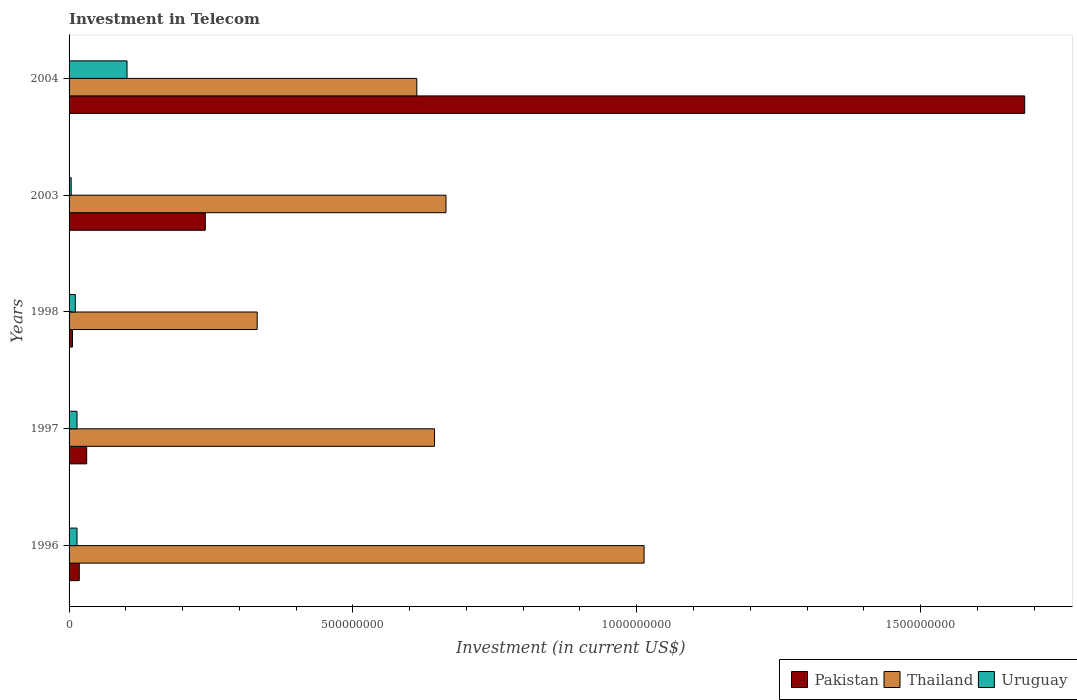How many different coloured bars are there?
Your response must be concise. 3. How many groups of bars are there?
Make the answer very short. 5. Are the number of bars per tick equal to the number of legend labels?
Your answer should be very brief. Yes. How many bars are there on the 4th tick from the top?
Provide a short and direct response. 3. How many bars are there on the 1st tick from the bottom?
Provide a short and direct response. 3. In how many cases, is the number of bars for a given year not equal to the number of legend labels?
Ensure brevity in your answer.  0. What is the amount invested in telecom in Thailand in 1997?
Your answer should be compact. 6.44e+08. Across all years, what is the maximum amount invested in telecom in Pakistan?
Your response must be concise. 1.68e+09. Across all years, what is the minimum amount invested in telecom in Pakistan?
Your response must be concise. 6.00e+06. In which year was the amount invested in telecom in Uruguay minimum?
Give a very brief answer. 2003. What is the total amount invested in telecom in Thailand in the graph?
Offer a very short reply. 3.26e+09. What is the difference between the amount invested in telecom in Uruguay in 1997 and that in 2003?
Your response must be concise. 1.03e+07. What is the difference between the amount invested in telecom in Thailand in 2004 and the amount invested in telecom in Uruguay in 1996?
Offer a very short reply. 5.99e+08. What is the average amount invested in telecom in Pakistan per year?
Provide a succinct answer. 3.96e+08. In the year 2004, what is the difference between the amount invested in telecom in Uruguay and amount invested in telecom in Thailand?
Provide a succinct answer. -5.10e+08. In how many years, is the amount invested in telecom in Uruguay greater than 900000000 US$?
Provide a succinct answer. 0. What is the ratio of the amount invested in telecom in Thailand in 1997 to that in 2004?
Keep it short and to the point. 1.05. What is the difference between the highest and the second highest amount invested in telecom in Pakistan?
Provide a short and direct response. 1.44e+09. What is the difference between the highest and the lowest amount invested in telecom in Uruguay?
Your answer should be compact. 9.84e+07. In how many years, is the amount invested in telecom in Uruguay greater than the average amount invested in telecom in Uruguay taken over all years?
Provide a succinct answer. 1. Is the sum of the amount invested in telecom in Uruguay in 1997 and 1998 greater than the maximum amount invested in telecom in Pakistan across all years?
Your answer should be very brief. No. What does the 2nd bar from the top in 1998 represents?
Offer a very short reply. Thailand. What does the 2nd bar from the bottom in 2004 represents?
Provide a short and direct response. Thailand. Is it the case that in every year, the sum of the amount invested in telecom in Pakistan and amount invested in telecom in Thailand is greater than the amount invested in telecom in Uruguay?
Provide a short and direct response. Yes. Are all the bars in the graph horizontal?
Give a very brief answer. Yes. Does the graph contain grids?
Give a very brief answer. No. How many legend labels are there?
Your answer should be very brief. 3. What is the title of the graph?
Your response must be concise. Investment in Telecom. What is the label or title of the X-axis?
Offer a very short reply. Investment (in current US$). What is the label or title of the Y-axis?
Offer a terse response. Years. What is the Investment (in current US$) of Pakistan in 1996?
Your answer should be very brief. 1.80e+07. What is the Investment (in current US$) in Thailand in 1996?
Your answer should be very brief. 1.01e+09. What is the Investment (in current US$) in Uruguay in 1996?
Provide a short and direct response. 1.40e+07. What is the Investment (in current US$) of Pakistan in 1997?
Your answer should be compact. 3.10e+07. What is the Investment (in current US$) in Thailand in 1997?
Offer a terse response. 6.44e+08. What is the Investment (in current US$) in Uruguay in 1997?
Your answer should be compact. 1.40e+07. What is the Investment (in current US$) in Thailand in 1998?
Your answer should be very brief. 3.31e+08. What is the Investment (in current US$) of Uruguay in 1998?
Offer a terse response. 1.10e+07. What is the Investment (in current US$) of Pakistan in 2003?
Provide a succinct answer. 2.40e+08. What is the Investment (in current US$) in Thailand in 2003?
Offer a very short reply. 6.64e+08. What is the Investment (in current US$) of Uruguay in 2003?
Provide a short and direct response. 3.70e+06. What is the Investment (in current US$) in Pakistan in 2004?
Keep it short and to the point. 1.68e+09. What is the Investment (in current US$) in Thailand in 2004?
Provide a short and direct response. 6.13e+08. What is the Investment (in current US$) of Uruguay in 2004?
Your answer should be compact. 1.02e+08. Across all years, what is the maximum Investment (in current US$) in Pakistan?
Make the answer very short. 1.68e+09. Across all years, what is the maximum Investment (in current US$) of Thailand?
Offer a terse response. 1.01e+09. Across all years, what is the maximum Investment (in current US$) of Uruguay?
Your answer should be compact. 1.02e+08. Across all years, what is the minimum Investment (in current US$) of Thailand?
Ensure brevity in your answer.  3.31e+08. Across all years, what is the minimum Investment (in current US$) in Uruguay?
Make the answer very short. 3.70e+06. What is the total Investment (in current US$) of Pakistan in the graph?
Your answer should be compact. 1.98e+09. What is the total Investment (in current US$) of Thailand in the graph?
Offer a very short reply. 3.26e+09. What is the total Investment (in current US$) in Uruguay in the graph?
Give a very brief answer. 1.45e+08. What is the difference between the Investment (in current US$) of Pakistan in 1996 and that in 1997?
Your answer should be compact. -1.30e+07. What is the difference between the Investment (in current US$) of Thailand in 1996 and that in 1997?
Keep it short and to the point. 3.69e+08. What is the difference between the Investment (in current US$) of Thailand in 1996 and that in 1998?
Ensure brevity in your answer.  6.82e+08. What is the difference between the Investment (in current US$) of Pakistan in 1996 and that in 2003?
Keep it short and to the point. -2.22e+08. What is the difference between the Investment (in current US$) of Thailand in 1996 and that in 2003?
Provide a succinct answer. 3.49e+08. What is the difference between the Investment (in current US$) in Uruguay in 1996 and that in 2003?
Ensure brevity in your answer.  1.03e+07. What is the difference between the Investment (in current US$) in Pakistan in 1996 and that in 2004?
Provide a short and direct response. -1.67e+09. What is the difference between the Investment (in current US$) of Thailand in 1996 and that in 2004?
Your answer should be compact. 4.00e+08. What is the difference between the Investment (in current US$) of Uruguay in 1996 and that in 2004?
Your response must be concise. -8.81e+07. What is the difference between the Investment (in current US$) in Pakistan in 1997 and that in 1998?
Provide a short and direct response. 2.50e+07. What is the difference between the Investment (in current US$) in Thailand in 1997 and that in 1998?
Offer a very short reply. 3.12e+08. What is the difference between the Investment (in current US$) in Uruguay in 1997 and that in 1998?
Provide a succinct answer. 3.00e+06. What is the difference between the Investment (in current US$) of Pakistan in 1997 and that in 2003?
Your answer should be compact. -2.09e+08. What is the difference between the Investment (in current US$) of Thailand in 1997 and that in 2003?
Give a very brief answer. -2.02e+07. What is the difference between the Investment (in current US$) of Uruguay in 1997 and that in 2003?
Offer a terse response. 1.03e+07. What is the difference between the Investment (in current US$) in Pakistan in 1997 and that in 2004?
Provide a short and direct response. -1.65e+09. What is the difference between the Investment (in current US$) in Thailand in 1997 and that in 2004?
Offer a terse response. 3.12e+07. What is the difference between the Investment (in current US$) of Uruguay in 1997 and that in 2004?
Provide a succinct answer. -8.81e+07. What is the difference between the Investment (in current US$) of Pakistan in 1998 and that in 2003?
Your answer should be very brief. -2.34e+08. What is the difference between the Investment (in current US$) of Thailand in 1998 and that in 2003?
Keep it short and to the point. -3.33e+08. What is the difference between the Investment (in current US$) of Uruguay in 1998 and that in 2003?
Offer a very short reply. 7.30e+06. What is the difference between the Investment (in current US$) of Pakistan in 1998 and that in 2004?
Give a very brief answer. -1.68e+09. What is the difference between the Investment (in current US$) in Thailand in 1998 and that in 2004?
Provide a short and direct response. -2.81e+08. What is the difference between the Investment (in current US$) of Uruguay in 1998 and that in 2004?
Offer a terse response. -9.11e+07. What is the difference between the Investment (in current US$) of Pakistan in 2003 and that in 2004?
Ensure brevity in your answer.  -1.44e+09. What is the difference between the Investment (in current US$) in Thailand in 2003 and that in 2004?
Offer a very short reply. 5.14e+07. What is the difference between the Investment (in current US$) in Uruguay in 2003 and that in 2004?
Your response must be concise. -9.84e+07. What is the difference between the Investment (in current US$) in Pakistan in 1996 and the Investment (in current US$) in Thailand in 1997?
Offer a very short reply. -6.26e+08. What is the difference between the Investment (in current US$) in Pakistan in 1996 and the Investment (in current US$) in Uruguay in 1997?
Keep it short and to the point. 4.00e+06. What is the difference between the Investment (in current US$) of Thailand in 1996 and the Investment (in current US$) of Uruguay in 1997?
Your answer should be very brief. 9.99e+08. What is the difference between the Investment (in current US$) in Pakistan in 1996 and the Investment (in current US$) in Thailand in 1998?
Keep it short and to the point. -3.13e+08. What is the difference between the Investment (in current US$) of Thailand in 1996 and the Investment (in current US$) of Uruguay in 1998?
Make the answer very short. 1.00e+09. What is the difference between the Investment (in current US$) of Pakistan in 1996 and the Investment (in current US$) of Thailand in 2003?
Offer a terse response. -6.46e+08. What is the difference between the Investment (in current US$) of Pakistan in 1996 and the Investment (in current US$) of Uruguay in 2003?
Your response must be concise. 1.43e+07. What is the difference between the Investment (in current US$) in Thailand in 1996 and the Investment (in current US$) in Uruguay in 2003?
Ensure brevity in your answer.  1.01e+09. What is the difference between the Investment (in current US$) of Pakistan in 1996 and the Investment (in current US$) of Thailand in 2004?
Offer a terse response. -5.95e+08. What is the difference between the Investment (in current US$) of Pakistan in 1996 and the Investment (in current US$) of Uruguay in 2004?
Ensure brevity in your answer.  -8.41e+07. What is the difference between the Investment (in current US$) of Thailand in 1996 and the Investment (in current US$) of Uruguay in 2004?
Your answer should be compact. 9.11e+08. What is the difference between the Investment (in current US$) of Pakistan in 1997 and the Investment (in current US$) of Thailand in 1998?
Offer a very short reply. -3.00e+08. What is the difference between the Investment (in current US$) of Pakistan in 1997 and the Investment (in current US$) of Uruguay in 1998?
Offer a terse response. 2.00e+07. What is the difference between the Investment (in current US$) in Thailand in 1997 and the Investment (in current US$) in Uruguay in 1998?
Your response must be concise. 6.33e+08. What is the difference between the Investment (in current US$) in Pakistan in 1997 and the Investment (in current US$) in Thailand in 2003?
Keep it short and to the point. -6.33e+08. What is the difference between the Investment (in current US$) of Pakistan in 1997 and the Investment (in current US$) of Uruguay in 2003?
Your response must be concise. 2.73e+07. What is the difference between the Investment (in current US$) in Thailand in 1997 and the Investment (in current US$) in Uruguay in 2003?
Keep it short and to the point. 6.40e+08. What is the difference between the Investment (in current US$) in Pakistan in 1997 and the Investment (in current US$) in Thailand in 2004?
Offer a terse response. -5.82e+08. What is the difference between the Investment (in current US$) of Pakistan in 1997 and the Investment (in current US$) of Uruguay in 2004?
Offer a terse response. -7.11e+07. What is the difference between the Investment (in current US$) in Thailand in 1997 and the Investment (in current US$) in Uruguay in 2004?
Your answer should be compact. 5.42e+08. What is the difference between the Investment (in current US$) of Pakistan in 1998 and the Investment (in current US$) of Thailand in 2003?
Keep it short and to the point. -6.58e+08. What is the difference between the Investment (in current US$) in Pakistan in 1998 and the Investment (in current US$) in Uruguay in 2003?
Your answer should be compact. 2.30e+06. What is the difference between the Investment (in current US$) in Thailand in 1998 and the Investment (in current US$) in Uruguay in 2003?
Offer a very short reply. 3.28e+08. What is the difference between the Investment (in current US$) of Pakistan in 1998 and the Investment (in current US$) of Thailand in 2004?
Keep it short and to the point. -6.07e+08. What is the difference between the Investment (in current US$) of Pakistan in 1998 and the Investment (in current US$) of Uruguay in 2004?
Make the answer very short. -9.61e+07. What is the difference between the Investment (in current US$) of Thailand in 1998 and the Investment (in current US$) of Uruguay in 2004?
Keep it short and to the point. 2.29e+08. What is the difference between the Investment (in current US$) of Pakistan in 2003 and the Investment (in current US$) of Thailand in 2004?
Give a very brief answer. -3.73e+08. What is the difference between the Investment (in current US$) in Pakistan in 2003 and the Investment (in current US$) in Uruguay in 2004?
Keep it short and to the point. 1.38e+08. What is the difference between the Investment (in current US$) in Thailand in 2003 and the Investment (in current US$) in Uruguay in 2004?
Keep it short and to the point. 5.62e+08. What is the average Investment (in current US$) in Pakistan per year?
Give a very brief answer. 3.96e+08. What is the average Investment (in current US$) of Thailand per year?
Keep it short and to the point. 6.53e+08. What is the average Investment (in current US$) in Uruguay per year?
Provide a succinct answer. 2.90e+07. In the year 1996, what is the difference between the Investment (in current US$) of Pakistan and Investment (in current US$) of Thailand?
Your answer should be very brief. -9.95e+08. In the year 1996, what is the difference between the Investment (in current US$) of Thailand and Investment (in current US$) of Uruguay?
Provide a short and direct response. 9.99e+08. In the year 1997, what is the difference between the Investment (in current US$) in Pakistan and Investment (in current US$) in Thailand?
Your answer should be compact. -6.13e+08. In the year 1997, what is the difference between the Investment (in current US$) in Pakistan and Investment (in current US$) in Uruguay?
Offer a terse response. 1.70e+07. In the year 1997, what is the difference between the Investment (in current US$) of Thailand and Investment (in current US$) of Uruguay?
Your response must be concise. 6.30e+08. In the year 1998, what is the difference between the Investment (in current US$) in Pakistan and Investment (in current US$) in Thailand?
Give a very brief answer. -3.25e+08. In the year 1998, what is the difference between the Investment (in current US$) in Pakistan and Investment (in current US$) in Uruguay?
Offer a terse response. -5.00e+06. In the year 1998, what is the difference between the Investment (in current US$) in Thailand and Investment (in current US$) in Uruguay?
Your response must be concise. 3.20e+08. In the year 2003, what is the difference between the Investment (in current US$) in Pakistan and Investment (in current US$) in Thailand?
Keep it short and to the point. -4.24e+08. In the year 2003, what is the difference between the Investment (in current US$) in Pakistan and Investment (in current US$) in Uruguay?
Offer a terse response. 2.36e+08. In the year 2003, what is the difference between the Investment (in current US$) of Thailand and Investment (in current US$) of Uruguay?
Your response must be concise. 6.60e+08. In the year 2004, what is the difference between the Investment (in current US$) of Pakistan and Investment (in current US$) of Thailand?
Keep it short and to the point. 1.07e+09. In the year 2004, what is the difference between the Investment (in current US$) in Pakistan and Investment (in current US$) in Uruguay?
Your answer should be very brief. 1.58e+09. In the year 2004, what is the difference between the Investment (in current US$) of Thailand and Investment (in current US$) of Uruguay?
Provide a short and direct response. 5.10e+08. What is the ratio of the Investment (in current US$) in Pakistan in 1996 to that in 1997?
Your answer should be compact. 0.58. What is the ratio of the Investment (in current US$) in Thailand in 1996 to that in 1997?
Your response must be concise. 1.57. What is the ratio of the Investment (in current US$) of Thailand in 1996 to that in 1998?
Keep it short and to the point. 3.06. What is the ratio of the Investment (in current US$) of Uruguay in 1996 to that in 1998?
Ensure brevity in your answer.  1.27. What is the ratio of the Investment (in current US$) of Pakistan in 1996 to that in 2003?
Ensure brevity in your answer.  0.07. What is the ratio of the Investment (in current US$) in Thailand in 1996 to that in 2003?
Offer a terse response. 1.53. What is the ratio of the Investment (in current US$) in Uruguay in 1996 to that in 2003?
Give a very brief answer. 3.78. What is the ratio of the Investment (in current US$) in Pakistan in 1996 to that in 2004?
Provide a succinct answer. 0.01. What is the ratio of the Investment (in current US$) in Thailand in 1996 to that in 2004?
Make the answer very short. 1.65. What is the ratio of the Investment (in current US$) of Uruguay in 1996 to that in 2004?
Give a very brief answer. 0.14. What is the ratio of the Investment (in current US$) of Pakistan in 1997 to that in 1998?
Provide a short and direct response. 5.17. What is the ratio of the Investment (in current US$) in Thailand in 1997 to that in 1998?
Provide a short and direct response. 1.94. What is the ratio of the Investment (in current US$) of Uruguay in 1997 to that in 1998?
Provide a short and direct response. 1.27. What is the ratio of the Investment (in current US$) of Pakistan in 1997 to that in 2003?
Keep it short and to the point. 0.13. What is the ratio of the Investment (in current US$) of Thailand in 1997 to that in 2003?
Make the answer very short. 0.97. What is the ratio of the Investment (in current US$) in Uruguay in 1997 to that in 2003?
Offer a very short reply. 3.78. What is the ratio of the Investment (in current US$) of Pakistan in 1997 to that in 2004?
Give a very brief answer. 0.02. What is the ratio of the Investment (in current US$) of Thailand in 1997 to that in 2004?
Your answer should be compact. 1.05. What is the ratio of the Investment (in current US$) of Uruguay in 1997 to that in 2004?
Provide a short and direct response. 0.14. What is the ratio of the Investment (in current US$) in Pakistan in 1998 to that in 2003?
Keep it short and to the point. 0.03. What is the ratio of the Investment (in current US$) of Thailand in 1998 to that in 2003?
Ensure brevity in your answer.  0.5. What is the ratio of the Investment (in current US$) of Uruguay in 1998 to that in 2003?
Your response must be concise. 2.97. What is the ratio of the Investment (in current US$) in Pakistan in 1998 to that in 2004?
Ensure brevity in your answer.  0. What is the ratio of the Investment (in current US$) in Thailand in 1998 to that in 2004?
Provide a short and direct response. 0.54. What is the ratio of the Investment (in current US$) of Uruguay in 1998 to that in 2004?
Your response must be concise. 0.11. What is the ratio of the Investment (in current US$) in Pakistan in 2003 to that in 2004?
Provide a succinct answer. 0.14. What is the ratio of the Investment (in current US$) of Thailand in 2003 to that in 2004?
Provide a short and direct response. 1.08. What is the ratio of the Investment (in current US$) of Uruguay in 2003 to that in 2004?
Your answer should be compact. 0.04. What is the difference between the highest and the second highest Investment (in current US$) of Pakistan?
Offer a very short reply. 1.44e+09. What is the difference between the highest and the second highest Investment (in current US$) of Thailand?
Provide a short and direct response. 3.49e+08. What is the difference between the highest and the second highest Investment (in current US$) of Uruguay?
Provide a succinct answer. 8.81e+07. What is the difference between the highest and the lowest Investment (in current US$) in Pakistan?
Ensure brevity in your answer.  1.68e+09. What is the difference between the highest and the lowest Investment (in current US$) of Thailand?
Ensure brevity in your answer.  6.82e+08. What is the difference between the highest and the lowest Investment (in current US$) of Uruguay?
Offer a terse response. 9.84e+07. 